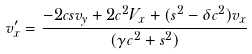<formula> <loc_0><loc_0><loc_500><loc_500>v _ { x } ^ { \prime } = \frac { - 2 c s v _ { y } + 2 c ^ { 2 } V _ { x } + ( s ^ { 2 } - \delta c ^ { 2 } ) v _ { x } } { ( \gamma c ^ { 2 } + s ^ { 2 } ) }</formula> 